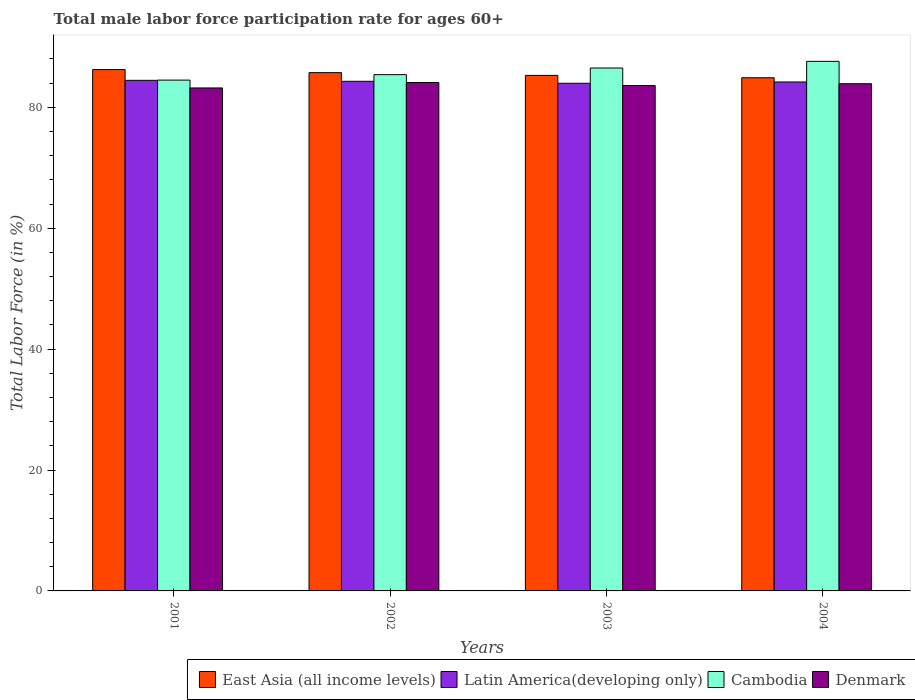Are the number of bars on each tick of the X-axis equal?
Give a very brief answer. Yes. How many bars are there on the 4th tick from the right?
Provide a short and direct response. 4. What is the label of the 3rd group of bars from the left?
Your answer should be compact. 2003. What is the male labor force participation rate in Cambodia in 2002?
Keep it short and to the point. 85.4. Across all years, what is the maximum male labor force participation rate in Cambodia?
Ensure brevity in your answer.  87.6. Across all years, what is the minimum male labor force participation rate in Cambodia?
Keep it short and to the point. 84.5. In which year was the male labor force participation rate in Denmark minimum?
Ensure brevity in your answer.  2001. What is the total male labor force participation rate in East Asia (all income levels) in the graph?
Your answer should be very brief. 342.14. What is the difference between the male labor force participation rate in Cambodia in 2003 and that in 2004?
Offer a very short reply. -1.1. What is the difference between the male labor force participation rate in East Asia (all income levels) in 2002 and the male labor force participation rate in Cambodia in 2004?
Your response must be concise. -1.87. What is the average male labor force participation rate in Cambodia per year?
Offer a very short reply. 86. In the year 2002, what is the difference between the male labor force participation rate in East Asia (all income levels) and male labor force participation rate in Cambodia?
Make the answer very short. 0.33. In how many years, is the male labor force participation rate in Denmark greater than 64 %?
Offer a very short reply. 4. What is the ratio of the male labor force participation rate in East Asia (all income levels) in 2001 to that in 2002?
Offer a very short reply. 1.01. Is the difference between the male labor force participation rate in East Asia (all income levels) in 2002 and 2004 greater than the difference between the male labor force participation rate in Cambodia in 2002 and 2004?
Your answer should be very brief. Yes. What is the difference between the highest and the second highest male labor force participation rate in Denmark?
Give a very brief answer. 0.2. What is the difference between the highest and the lowest male labor force participation rate in Denmark?
Make the answer very short. 0.9. Is the sum of the male labor force participation rate in Latin America(developing only) in 2002 and 2004 greater than the maximum male labor force participation rate in Cambodia across all years?
Ensure brevity in your answer.  Yes. What does the 2nd bar from the left in 2003 represents?
Ensure brevity in your answer.  Latin America(developing only). Is it the case that in every year, the sum of the male labor force participation rate in Denmark and male labor force participation rate in Latin America(developing only) is greater than the male labor force participation rate in Cambodia?
Keep it short and to the point. Yes. Are all the bars in the graph horizontal?
Give a very brief answer. No. Where does the legend appear in the graph?
Ensure brevity in your answer.  Bottom right. How are the legend labels stacked?
Your answer should be very brief. Horizontal. What is the title of the graph?
Your response must be concise. Total male labor force participation rate for ages 60+. Does "Iran" appear as one of the legend labels in the graph?
Ensure brevity in your answer.  No. What is the label or title of the X-axis?
Your response must be concise. Years. What is the label or title of the Y-axis?
Your answer should be very brief. Total Labor Force (in %). What is the Total Labor Force (in %) of East Asia (all income levels) in 2001?
Provide a short and direct response. 86.24. What is the Total Labor Force (in %) of Latin America(developing only) in 2001?
Offer a very short reply. 84.46. What is the Total Labor Force (in %) of Cambodia in 2001?
Offer a very short reply. 84.5. What is the Total Labor Force (in %) of Denmark in 2001?
Your answer should be very brief. 83.2. What is the Total Labor Force (in %) of East Asia (all income levels) in 2002?
Offer a terse response. 85.73. What is the Total Labor Force (in %) of Latin America(developing only) in 2002?
Keep it short and to the point. 84.3. What is the Total Labor Force (in %) in Cambodia in 2002?
Offer a very short reply. 85.4. What is the Total Labor Force (in %) of Denmark in 2002?
Keep it short and to the point. 84.1. What is the Total Labor Force (in %) in East Asia (all income levels) in 2003?
Your answer should be very brief. 85.28. What is the Total Labor Force (in %) in Latin America(developing only) in 2003?
Your answer should be compact. 83.97. What is the Total Labor Force (in %) in Cambodia in 2003?
Your response must be concise. 86.5. What is the Total Labor Force (in %) in Denmark in 2003?
Ensure brevity in your answer.  83.6. What is the Total Labor Force (in %) of East Asia (all income levels) in 2004?
Give a very brief answer. 84.89. What is the Total Labor Force (in %) in Latin America(developing only) in 2004?
Give a very brief answer. 84.19. What is the Total Labor Force (in %) in Cambodia in 2004?
Offer a terse response. 87.6. What is the Total Labor Force (in %) in Denmark in 2004?
Offer a terse response. 83.9. Across all years, what is the maximum Total Labor Force (in %) of East Asia (all income levels)?
Provide a succinct answer. 86.24. Across all years, what is the maximum Total Labor Force (in %) in Latin America(developing only)?
Provide a short and direct response. 84.46. Across all years, what is the maximum Total Labor Force (in %) of Cambodia?
Provide a short and direct response. 87.6. Across all years, what is the maximum Total Labor Force (in %) of Denmark?
Provide a succinct answer. 84.1. Across all years, what is the minimum Total Labor Force (in %) of East Asia (all income levels)?
Ensure brevity in your answer.  84.89. Across all years, what is the minimum Total Labor Force (in %) of Latin America(developing only)?
Make the answer very short. 83.97. Across all years, what is the minimum Total Labor Force (in %) of Cambodia?
Your answer should be very brief. 84.5. Across all years, what is the minimum Total Labor Force (in %) of Denmark?
Offer a terse response. 83.2. What is the total Total Labor Force (in %) in East Asia (all income levels) in the graph?
Your answer should be compact. 342.14. What is the total Total Labor Force (in %) in Latin America(developing only) in the graph?
Your answer should be compact. 336.92. What is the total Total Labor Force (in %) in Cambodia in the graph?
Offer a very short reply. 344. What is the total Total Labor Force (in %) in Denmark in the graph?
Your response must be concise. 334.8. What is the difference between the Total Labor Force (in %) of East Asia (all income levels) in 2001 and that in 2002?
Keep it short and to the point. 0.51. What is the difference between the Total Labor Force (in %) of Latin America(developing only) in 2001 and that in 2002?
Ensure brevity in your answer.  0.16. What is the difference between the Total Labor Force (in %) of Denmark in 2001 and that in 2002?
Your answer should be compact. -0.9. What is the difference between the Total Labor Force (in %) of East Asia (all income levels) in 2001 and that in 2003?
Make the answer very short. 0.96. What is the difference between the Total Labor Force (in %) of Latin America(developing only) in 2001 and that in 2003?
Make the answer very short. 0.49. What is the difference between the Total Labor Force (in %) in Cambodia in 2001 and that in 2003?
Ensure brevity in your answer.  -2. What is the difference between the Total Labor Force (in %) in Denmark in 2001 and that in 2003?
Keep it short and to the point. -0.4. What is the difference between the Total Labor Force (in %) in East Asia (all income levels) in 2001 and that in 2004?
Provide a succinct answer. 1.35. What is the difference between the Total Labor Force (in %) of Latin America(developing only) in 2001 and that in 2004?
Keep it short and to the point. 0.27. What is the difference between the Total Labor Force (in %) of Cambodia in 2001 and that in 2004?
Provide a short and direct response. -3.1. What is the difference between the Total Labor Force (in %) in East Asia (all income levels) in 2002 and that in 2003?
Provide a short and direct response. 0.45. What is the difference between the Total Labor Force (in %) in Latin America(developing only) in 2002 and that in 2003?
Provide a succinct answer. 0.33. What is the difference between the Total Labor Force (in %) of Cambodia in 2002 and that in 2003?
Offer a terse response. -1.1. What is the difference between the Total Labor Force (in %) of Denmark in 2002 and that in 2003?
Your response must be concise. 0.5. What is the difference between the Total Labor Force (in %) of East Asia (all income levels) in 2002 and that in 2004?
Your answer should be compact. 0.84. What is the difference between the Total Labor Force (in %) of Latin America(developing only) in 2002 and that in 2004?
Make the answer very short. 0.11. What is the difference between the Total Labor Force (in %) in Denmark in 2002 and that in 2004?
Make the answer very short. 0.2. What is the difference between the Total Labor Force (in %) in East Asia (all income levels) in 2003 and that in 2004?
Offer a terse response. 0.39. What is the difference between the Total Labor Force (in %) in Latin America(developing only) in 2003 and that in 2004?
Your answer should be very brief. -0.22. What is the difference between the Total Labor Force (in %) of Denmark in 2003 and that in 2004?
Your answer should be compact. -0.3. What is the difference between the Total Labor Force (in %) in East Asia (all income levels) in 2001 and the Total Labor Force (in %) in Latin America(developing only) in 2002?
Keep it short and to the point. 1.94. What is the difference between the Total Labor Force (in %) in East Asia (all income levels) in 2001 and the Total Labor Force (in %) in Cambodia in 2002?
Your answer should be very brief. 0.84. What is the difference between the Total Labor Force (in %) of East Asia (all income levels) in 2001 and the Total Labor Force (in %) of Denmark in 2002?
Offer a terse response. 2.14. What is the difference between the Total Labor Force (in %) of Latin America(developing only) in 2001 and the Total Labor Force (in %) of Cambodia in 2002?
Keep it short and to the point. -0.94. What is the difference between the Total Labor Force (in %) of Latin America(developing only) in 2001 and the Total Labor Force (in %) of Denmark in 2002?
Provide a short and direct response. 0.36. What is the difference between the Total Labor Force (in %) in East Asia (all income levels) in 2001 and the Total Labor Force (in %) in Latin America(developing only) in 2003?
Offer a terse response. 2.27. What is the difference between the Total Labor Force (in %) of East Asia (all income levels) in 2001 and the Total Labor Force (in %) of Cambodia in 2003?
Provide a short and direct response. -0.26. What is the difference between the Total Labor Force (in %) in East Asia (all income levels) in 2001 and the Total Labor Force (in %) in Denmark in 2003?
Offer a very short reply. 2.64. What is the difference between the Total Labor Force (in %) in Latin America(developing only) in 2001 and the Total Labor Force (in %) in Cambodia in 2003?
Your answer should be very brief. -2.04. What is the difference between the Total Labor Force (in %) in Latin America(developing only) in 2001 and the Total Labor Force (in %) in Denmark in 2003?
Make the answer very short. 0.86. What is the difference between the Total Labor Force (in %) in Cambodia in 2001 and the Total Labor Force (in %) in Denmark in 2003?
Your response must be concise. 0.9. What is the difference between the Total Labor Force (in %) in East Asia (all income levels) in 2001 and the Total Labor Force (in %) in Latin America(developing only) in 2004?
Provide a succinct answer. 2.05. What is the difference between the Total Labor Force (in %) in East Asia (all income levels) in 2001 and the Total Labor Force (in %) in Cambodia in 2004?
Give a very brief answer. -1.36. What is the difference between the Total Labor Force (in %) in East Asia (all income levels) in 2001 and the Total Labor Force (in %) in Denmark in 2004?
Provide a short and direct response. 2.34. What is the difference between the Total Labor Force (in %) of Latin America(developing only) in 2001 and the Total Labor Force (in %) of Cambodia in 2004?
Offer a terse response. -3.14. What is the difference between the Total Labor Force (in %) of Latin America(developing only) in 2001 and the Total Labor Force (in %) of Denmark in 2004?
Provide a short and direct response. 0.56. What is the difference between the Total Labor Force (in %) in East Asia (all income levels) in 2002 and the Total Labor Force (in %) in Latin America(developing only) in 2003?
Provide a short and direct response. 1.76. What is the difference between the Total Labor Force (in %) of East Asia (all income levels) in 2002 and the Total Labor Force (in %) of Cambodia in 2003?
Ensure brevity in your answer.  -0.77. What is the difference between the Total Labor Force (in %) of East Asia (all income levels) in 2002 and the Total Labor Force (in %) of Denmark in 2003?
Offer a very short reply. 2.13. What is the difference between the Total Labor Force (in %) of Latin America(developing only) in 2002 and the Total Labor Force (in %) of Cambodia in 2003?
Offer a very short reply. -2.2. What is the difference between the Total Labor Force (in %) of Latin America(developing only) in 2002 and the Total Labor Force (in %) of Denmark in 2003?
Ensure brevity in your answer.  0.7. What is the difference between the Total Labor Force (in %) in East Asia (all income levels) in 2002 and the Total Labor Force (in %) in Latin America(developing only) in 2004?
Make the answer very short. 1.54. What is the difference between the Total Labor Force (in %) of East Asia (all income levels) in 2002 and the Total Labor Force (in %) of Cambodia in 2004?
Give a very brief answer. -1.87. What is the difference between the Total Labor Force (in %) in East Asia (all income levels) in 2002 and the Total Labor Force (in %) in Denmark in 2004?
Offer a terse response. 1.83. What is the difference between the Total Labor Force (in %) of Latin America(developing only) in 2002 and the Total Labor Force (in %) of Cambodia in 2004?
Ensure brevity in your answer.  -3.3. What is the difference between the Total Labor Force (in %) in Latin America(developing only) in 2002 and the Total Labor Force (in %) in Denmark in 2004?
Your answer should be very brief. 0.4. What is the difference between the Total Labor Force (in %) of Cambodia in 2002 and the Total Labor Force (in %) of Denmark in 2004?
Provide a succinct answer. 1.5. What is the difference between the Total Labor Force (in %) of East Asia (all income levels) in 2003 and the Total Labor Force (in %) of Latin America(developing only) in 2004?
Provide a short and direct response. 1.09. What is the difference between the Total Labor Force (in %) of East Asia (all income levels) in 2003 and the Total Labor Force (in %) of Cambodia in 2004?
Provide a short and direct response. -2.32. What is the difference between the Total Labor Force (in %) in East Asia (all income levels) in 2003 and the Total Labor Force (in %) in Denmark in 2004?
Give a very brief answer. 1.38. What is the difference between the Total Labor Force (in %) of Latin America(developing only) in 2003 and the Total Labor Force (in %) of Cambodia in 2004?
Your response must be concise. -3.63. What is the difference between the Total Labor Force (in %) in Latin America(developing only) in 2003 and the Total Labor Force (in %) in Denmark in 2004?
Make the answer very short. 0.07. What is the difference between the Total Labor Force (in %) in Cambodia in 2003 and the Total Labor Force (in %) in Denmark in 2004?
Your answer should be compact. 2.6. What is the average Total Labor Force (in %) in East Asia (all income levels) per year?
Make the answer very short. 85.54. What is the average Total Labor Force (in %) in Latin America(developing only) per year?
Offer a very short reply. 84.23. What is the average Total Labor Force (in %) of Cambodia per year?
Give a very brief answer. 86. What is the average Total Labor Force (in %) in Denmark per year?
Provide a short and direct response. 83.7. In the year 2001, what is the difference between the Total Labor Force (in %) in East Asia (all income levels) and Total Labor Force (in %) in Latin America(developing only)?
Your answer should be very brief. 1.78. In the year 2001, what is the difference between the Total Labor Force (in %) in East Asia (all income levels) and Total Labor Force (in %) in Cambodia?
Your response must be concise. 1.74. In the year 2001, what is the difference between the Total Labor Force (in %) in East Asia (all income levels) and Total Labor Force (in %) in Denmark?
Your answer should be compact. 3.04. In the year 2001, what is the difference between the Total Labor Force (in %) in Latin America(developing only) and Total Labor Force (in %) in Cambodia?
Keep it short and to the point. -0.04. In the year 2001, what is the difference between the Total Labor Force (in %) in Latin America(developing only) and Total Labor Force (in %) in Denmark?
Your answer should be compact. 1.26. In the year 2002, what is the difference between the Total Labor Force (in %) of East Asia (all income levels) and Total Labor Force (in %) of Latin America(developing only)?
Make the answer very short. 1.43. In the year 2002, what is the difference between the Total Labor Force (in %) of East Asia (all income levels) and Total Labor Force (in %) of Cambodia?
Keep it short and to the point. 0.33. In the year 2002, what is the difference between the Total Labor Force (in %) of East Asia (all income levels) and Total Labor Force (in %) of Denmark?
Your answer should be very brief. 1.63. In the year 2002, what is the difference between the Total Labor Force (in %) of Latin America(developing only) and Total Labor Force (in %) of Cambodia?
Keep it short and to the point. -1.1. In the year 2002, what is the difference between the Total Labor Force (in %) of Latin America(developing only) and Total Labor Force (in %) of Denmark?
Keep it short and to the point. 0.2. In the year 2003, what is the difference between the Total Labor Force (in %) in East Asia (all income levels) and Total Labor Force (in %) in Latin America(developing only)?
Ensure brevity in your answer.  1.31. In the year 2003, what is the difference between the Total Labor Force (in %) in East Asia (all income levels) and Total Labor Force (in %) in Cambodia?
Provide a succinct answer. -1.22. In the year 2003, what is the difference between the Total Labor Force (in %) of East Asia (all income levels) and Total Labor Force (in %) of Denmark?
Provide a short and direct response. 1.68. In the year 2003, what is the difference between the Total Labor Force (in %) of Latin America(developing only) and Total Labor Force (in %) of Cambodia?
Ensure brevity in your answer.  -2.53. In the year 2003, what is the difference between the Total Labor Force (in %) of Latin America(developing only) and Total Labor Force (in %) of Denmark?
Your answer should be very brief. 0.37. In the year 2003, what is the difference between the Total Labor Force (in %) in Cambodia and Total Labor Force (in %) in Denmark?
Offer a very short reply. 2.9. In the year 2004, what is the difference between the Total Labor Force (in %) in East Asia (all income levels) and Total Labor Force (in %) in Latin America(developing only)?
Provide a short and direct response. 0.7. In the year 2004, what is the difference between the Total Labor Force (in %) in East Asia (all income levels) and Total Labor Force (in %) in Cambodia?
Offer a very short reply. -2.71. In the year 2004, what is the difference between the Total Labor Force (in %) of East Asia (all income levels) and Total Labor Force (in %) of Denmark?
Make the answer very short. 0.99. In the year 2004, what is the difference between the Total Labor Force (in %) in Latin America(developing only) and Total Labor Force (in %) in Cambodia?
Your response must be concise. -3.41. In the year 2004, what is the difference between the Total Labor Force (in %) in Latin America(developing only) and Total Labor Force (in %) in Denmark?
Provide a succinct answer. 0.29. What is the ratio of the Total Labor Force (in %) of Latin America(developing only) in 2001 to that in 2002?
Your answer should be very brief. 1. What is the ratio of the Total Labor Force (in %) in Cambodia in 2001 to that in 2002?
Your answer should be very brief. 0.99. What is the ratio of the Total Labor Force (in %) of Denmark in 2001 to that in 2002?
Offer a very short reply. 0.99. What is the ratio of the Total Labor Force (in %) in East Asia (all income levels) in 2001 to that in 2003?
Ensure brevity in your answer.  1.01. What is the ratio of the Total Labor Force (in %) of Cambodia in 2001 to that in 2003?
Your answer should be compact. 0.98. What is the ratio of the Total Labor Force (in %) in East Asia (all income levels) in 2001 to that in 2004?
Your answer should be very brief. 1.02. What is the ratio of the Total Labor Force (in %) of Cambodia in 2001 to that in 2004?
Provide a short and direct response. 0.96. What is the ratio of the Total Labor Force (in %) in East Asia (all income levels) in 2002 to that in 2003?
Your answer should be very brief. 1.01. What is the ratio of the Total Labor Force (in %) of Latin America(developing only) in 2002 to that in 2003?
Your response must be concise. 1. What is the ratio of the Total Labor Force (in %) of Cambodia in 2002 to that in 2003?
Keep it short and to the point. 0.99. What is the ratio of the Total Labor Force (in %) in Denmark in 2002 to that in 2003?
Keep it short and to the point. 1.01. What is the ratio of the Total Labor Force (in %) of East Asia (all income levels) in 2002 to that in 2004?
Your answer should be very brief. 1.01. What is the ratio of the Total Labor Force (in %) of Latin America(developing only) in 2002 to that in 2004?
Offer a terse response. 1. What is the ratio of the Total Labor Force (in %) of Cambodia in 2002 to that in 2004?
Give a very brief answer. 0.97. What is the ratio of the Total Labor Force (in %) of Denmark in 2002 to that in 2004?
Provide a short and direct response. 1. What is the ratio of the Total Labor Force (in %) of Cambodia in 2003 to that in 2004?
Keep it short and to the point. 0.99. What is the difference between the highest and the second highest Total Labor Force (in %) of East Asia (all income levels)?
Your answer should be compact. 0.51. What is the difference between the highest and the second highest Total Labor Force (in %) of Latin America(developing only)?
Give a very brief answer. 0.16. What is the difference between the highest and the lowest Total Labor Force (in %) in East Asia (all income levels)?
Keep it short and to the point. 1.35. What is the difference between the highest and the lowest Total Labor Force (in %) of Latin America(developing only)?
Keep it short and to the point. 0.49. What is the difference between the highest and the lowest Total Labor Force (in %) in Denmark?
Offer a very short reply. 0.9. 